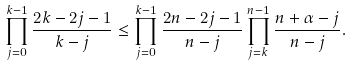Convert formula to latex. <formula><loc_0><loc_0><loc_500><loc_500>\prod _ { j = 0 } ^ { k - 1 } \frac { 2 k - 2 j - 1 } { k - j } \leq \prod _ { j = 0 } ^ { k - 1 } \frac { 2 n - 2 j - 1 } { n - j } \prod _ { j = k } ^ { n - 1 } \frac { n + \alpha - j } { n - j } .</formula> 